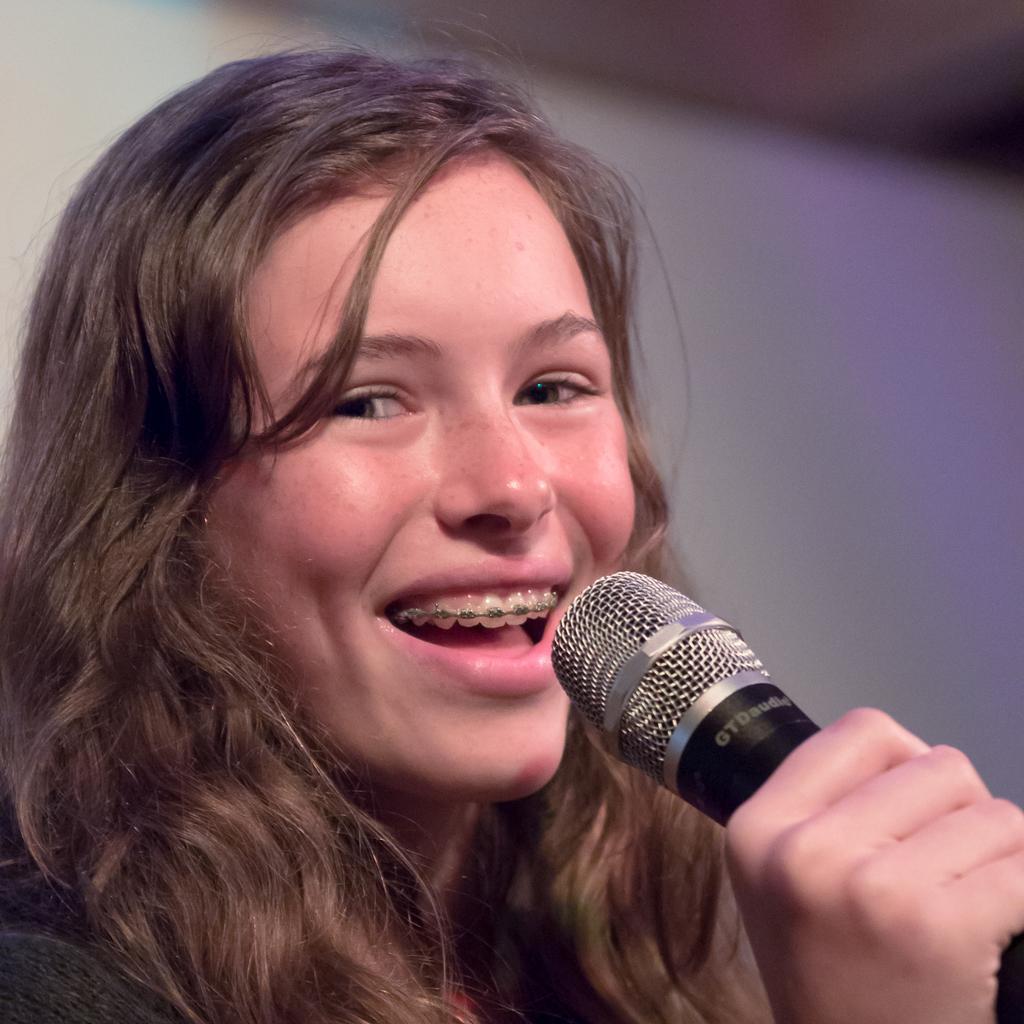How would you summarize this image in a sentence or two? In this there is a woman smiling and talking into microphone. 